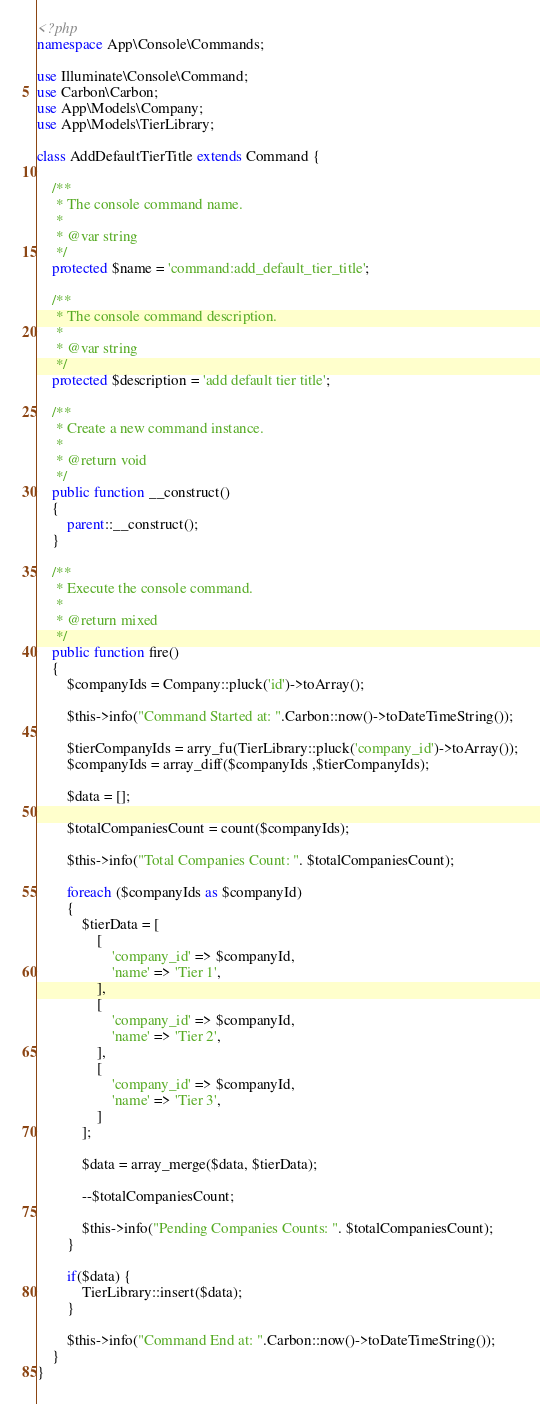Convert code to text. <code><loc_0><loc_0><loc_500><loc_500><_PHP_><?php
namespace App\Console\Commands;

use Illuminate\Console\Command;
use Carbon\Carbon;
use App\Models\Company;
use App\Models\TierLibrary;

class AddDefaultTierTitle extends Command {

	/**
	 * The console command name.
	 *
	 * @var string
	 */
	protected $name = 'command:add_default_tier_title';

	/**
	 * The console command description.
	 *
	 * @var string
	 */
	protected $description = 'add default tier title';

	/**
	 * Create a new command instance.
	 *
	 * @return void
	 */
	public function __construct()
	{
		parent::__construct();
	}

	/**
	 * Execute the console command.
	 *
	 * @return mixed
	 */
	public function fire()
	{
		$companyIds = Company::pluck('id')->toArray();

		$this->info("Command Started at: ".Carbon::now()->toDateTimeString());

		$tierCompanyIds = arry_fu(TierLibrary::pluck('company_id')->toArray());
		$companyIds = array_diff($companyIds ,$tierCompanyIds);

        $data = [];

        $totalCompaniesCount = count($companyIds);

        $this->info("Total Companies Count: ". $totalCompaniesCount);

        foreach ($companyIds as $companyId)
        {
        	$tierData = [
				[
					'company_id' => $companyId,
					'name' => 'Tier 1',
				],
				[
					'company_id' => $companyId,
					'name' => 'Tier 2',
				],
				[
					'company_id' => $companyId,
					'name' => 'Tier 3',
				]
			];

			$data = array_merge($data, $tierData);

			--$totalCompaniesCount;

			$this->info("Pending Companies Counts: ". $totalCompaniesCount);
        }

		if($data) {
			TierLibrary::insert($data);
		}

		$this->info("Command End at: ".Carbon::now()->toDateTimeString());
    }
}
</code> 